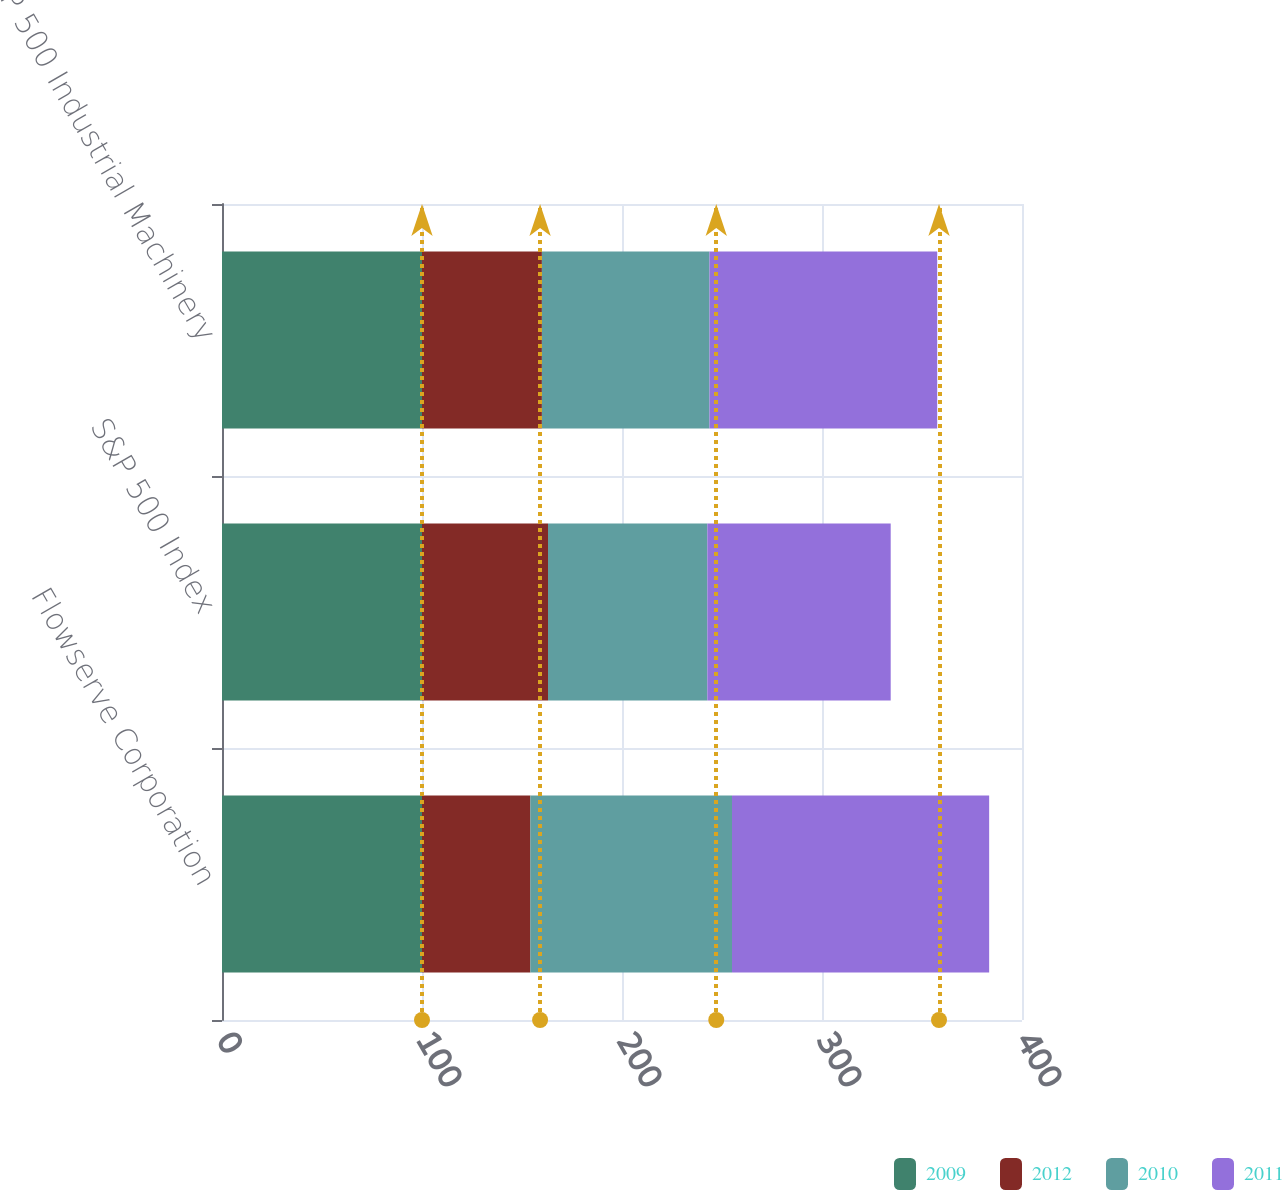Convert chart to OTSL. <chart><loc_0><loc_0><loc_500><loc_500><stacked_bar_chart><ecel><fcel>Flowserve Corporation<fcel>S&P 500 Index<fcel>S&P 500 Industrial Machinery<nl><fcel>2009<fcel>100<fcel>100<fcel>100<nl><fcel>2012<fcel>54.18<fcel>63<fcel>59.95<nl><fcel>2010<fcel>100.82<fcel>79.67<fcel>83.77<nl><fcel>2011<fcel>128.58<fcel>91.68<fcel>113.88<nl></chart> 